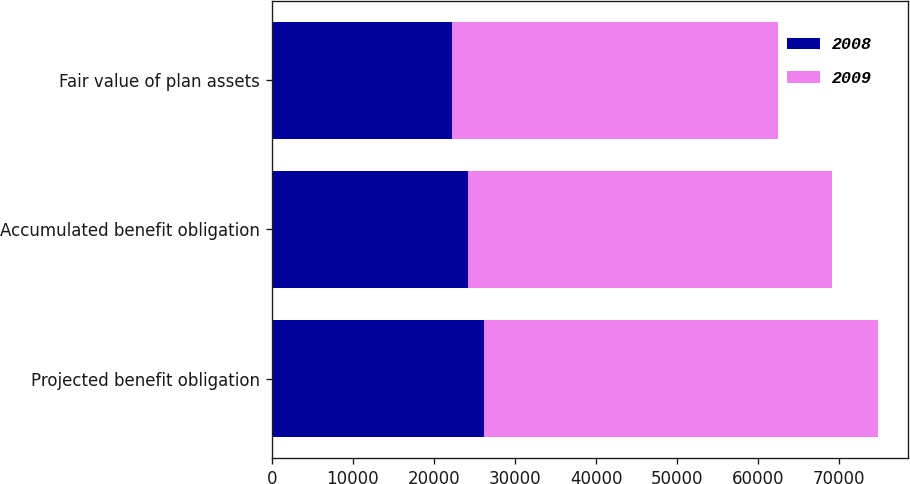Convert chart to OTSL. <chart><loc_0><loc_0><loc_500><loc_500><stacked_bar_chart><ecel><fcel>Projected benefit obligation<fcel>Accumulated benefit obligation<fcel>Fair value of plan assets<nl><fcel>2008<fcel>26141<fcel>24227<fcel>22205<nl><fcel>2009<fcel>48658<fcel>44863<fcel>40225<nl></chart> 